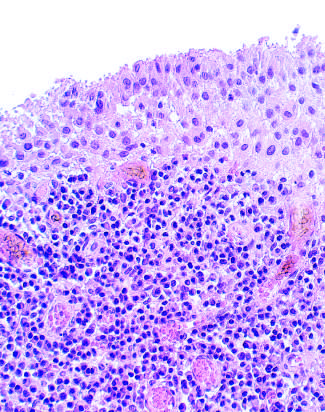what did subsynovial tissue contain?
Answer the question using a single word or phrase. A dense lymphoid aggregate 